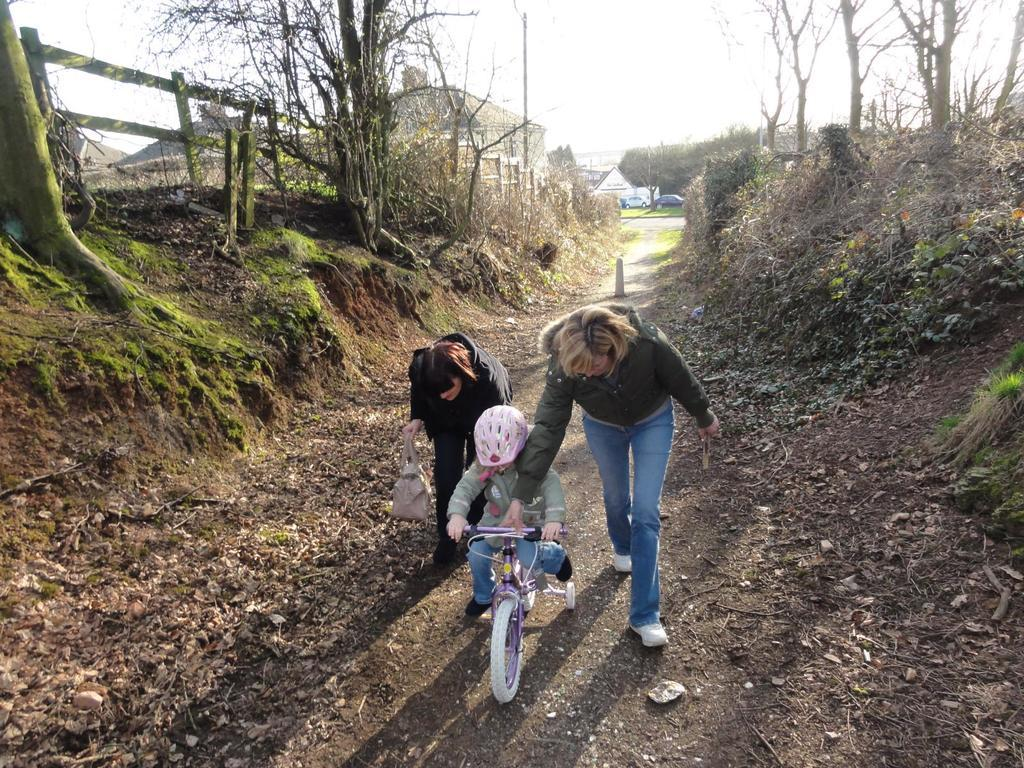How many people are in the image? There are two persons in the image. What are the two persons doing in the image? The two persons are holding a child. Where is the child positioned in the image? The child is in a bicycle. What can be seen in the background of the image? There are buildings, trees, and the sky visible in the background of the image. Are there any vehicles present in the image? Yes, there are vehicles in the background of the image. What type of pump can be seen in the image? There is no pump present in the image. How many spoons are visible in the image? There are no spoons visible in the image. 